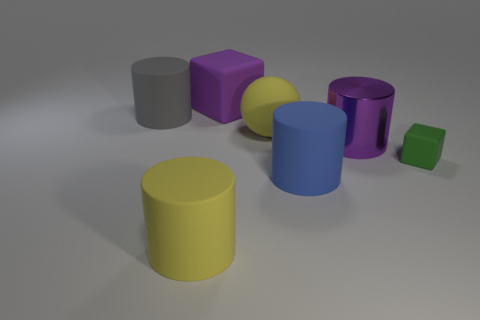Add 2 purple rubber cubes. How many objects exist? 9 Subtract all blocks. How many objects are left? 5 Subtract all tiny blue shiny cubes. Subtract all cylinders. How many objects are left? 3 Add 2 big blue rubber cylinders. How many big blue rubber cylinders are left? 3 Add 6 small blue cylinders. How many small blue cylinders exist? 6 Subtract 0 red blocks. How many objects are left? 7 